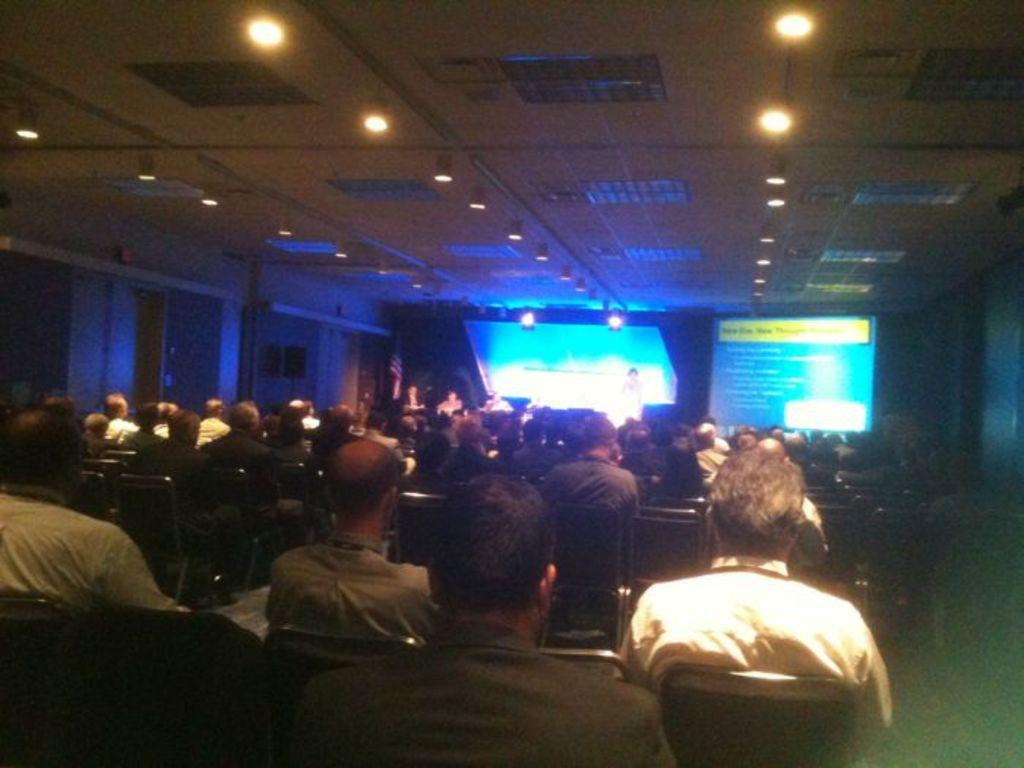What are the people in the image doing? There is a group of people sitting in the image. What can be seen in the background of the image? There is a projector screen and lights visible in the background of the image. What type of cannon is being fired in the image? There is no cannon present in the image; it features a group of people sitting and a projector screen in the background. What sound does the horn make in the image? There is no horn present in the image. 